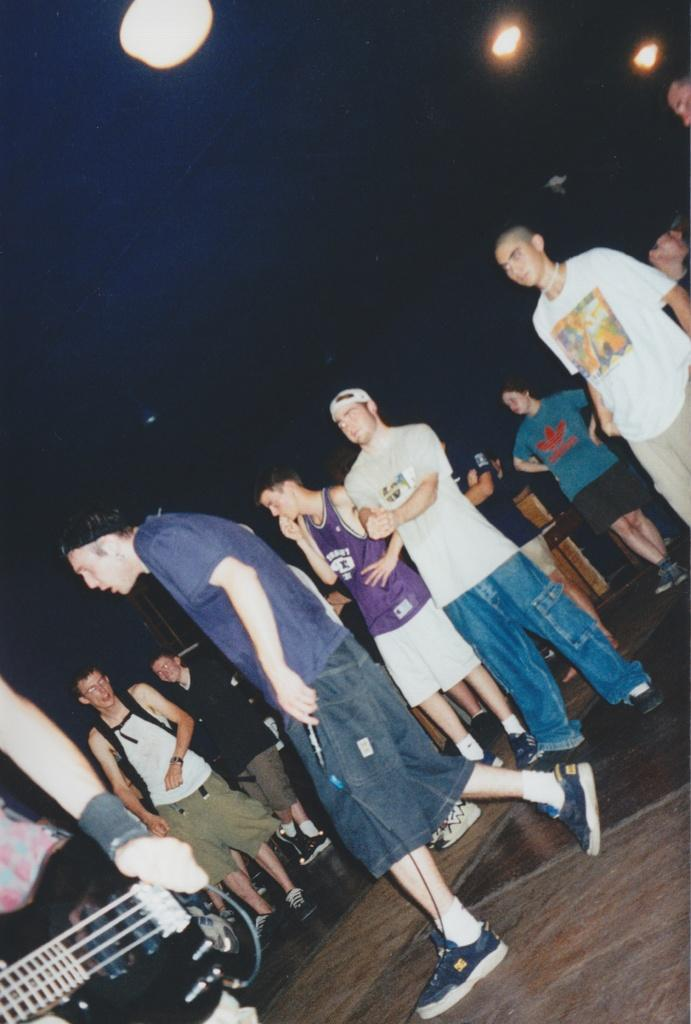Where was the image taken? The image was taken in a room. What can be seen in the foreground of the image? There is a group of people standing on the floor. What color is the background behind the people? The background of the people is black. How many lights are visible in the background? There are three lights visible in the background. What advice is being given to the group of people in the image? There is no indication in the image that anyone is giving advice to the group of people. 